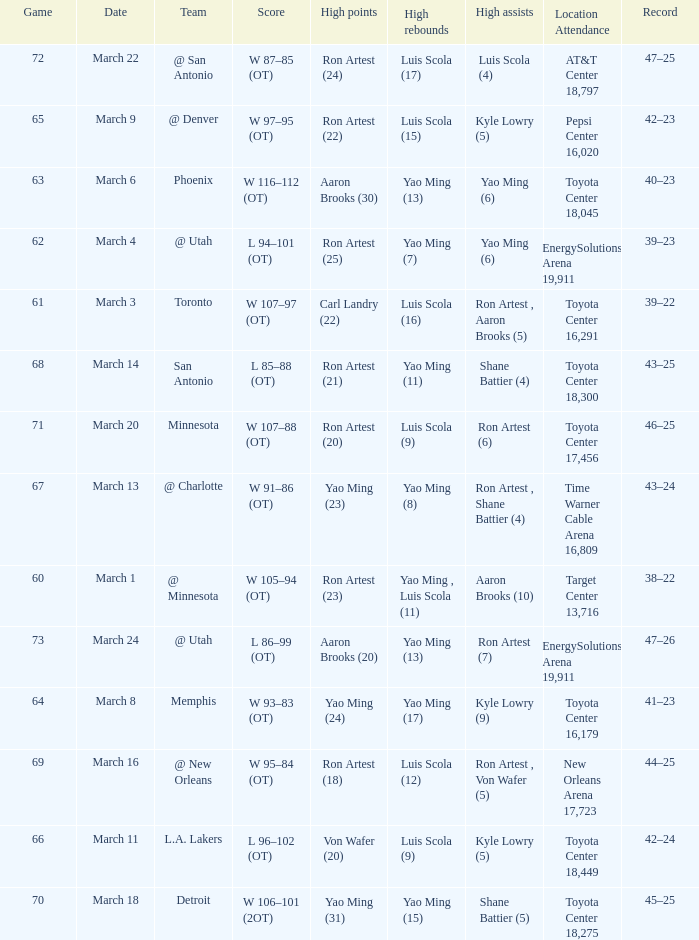On what date did the Rockets play Memphis? March 8. 